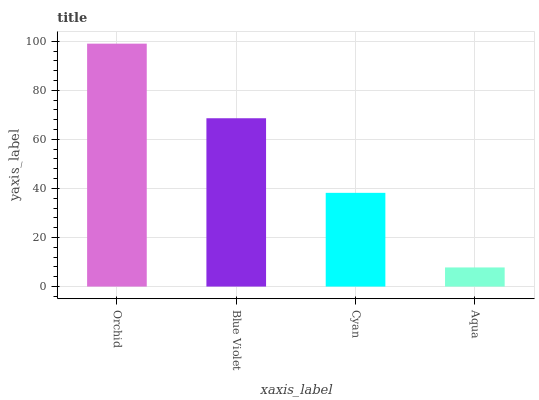Is Aqua the minimum?
Answer yes or no. Yes. Is Orchid the maximum?
Answer yes or no. Yes. Is Blue Violet the minimum?
Answer yes or no. No. Is Blue Violet the maximum?
Answer yes or no. No. Is Orchid greater than Blue Violet?
Answer yes or no. Yes. Is Blue Violet less than Orchid?
Answer yes or no. Yes. Is Blue Violet greater than Orchid?
Answer yes or no. No. Is Orchid less than Blue Violet?
Answer yes or no. No. Is Blue Violet the high median?
Answer yes or no. Yes. Is Cyan the low median?
Answer yes or no. Yes. Is Cyan the high median?
Answer yes or no. No. Is Blue Violet the low median?
Answer yes or no. No. 